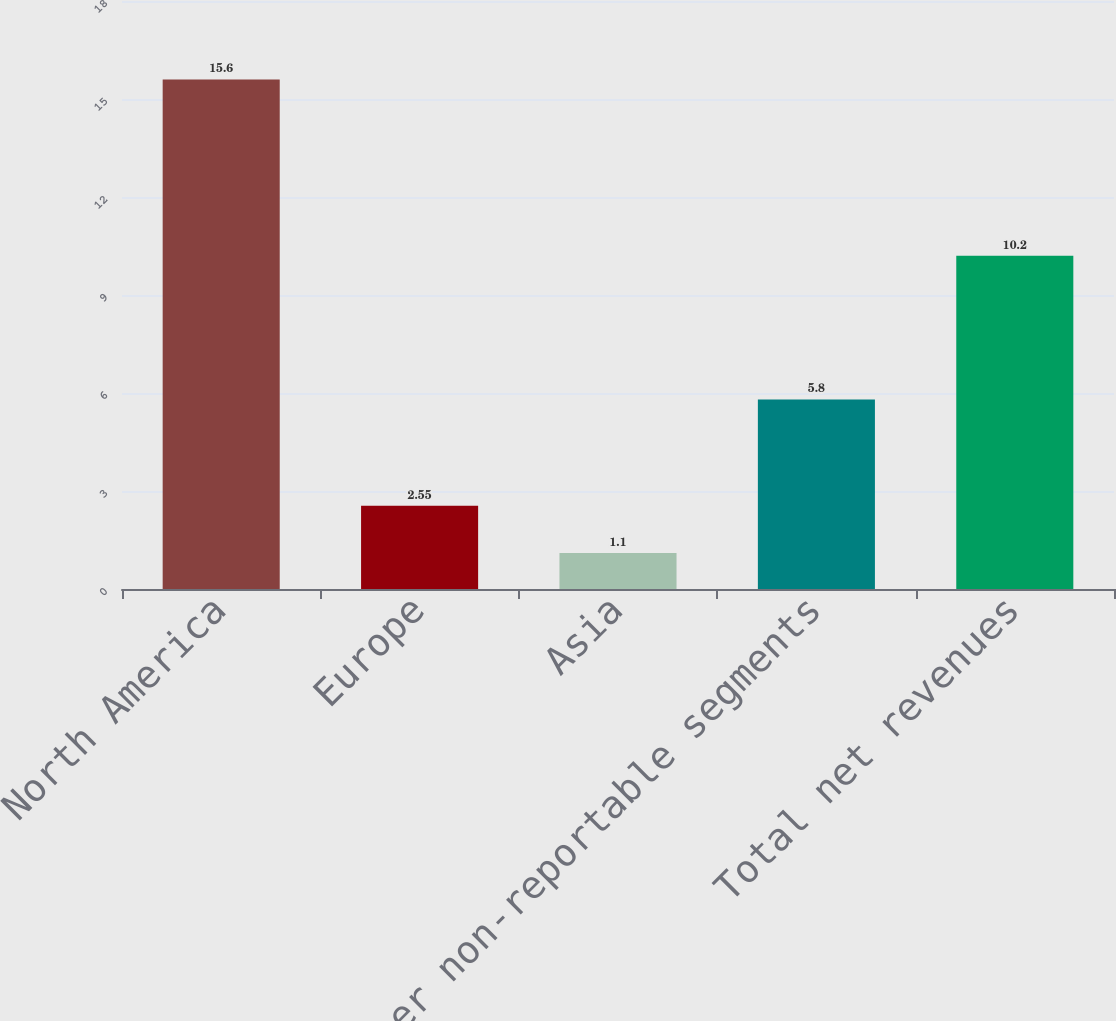Convert chart to OTSL. <chart><loc_0><loc_0><loc_500><loc_500><bar_chart><fcel>North America<fcel>Europe<fcel>Asia<fcel>Other non-reportable segments<fcel>Total net revenues<nl><fcel>15.6<fcel>2.55<fcel>1.1<fcel>5.8<fcel>10.2<nl></chart> 